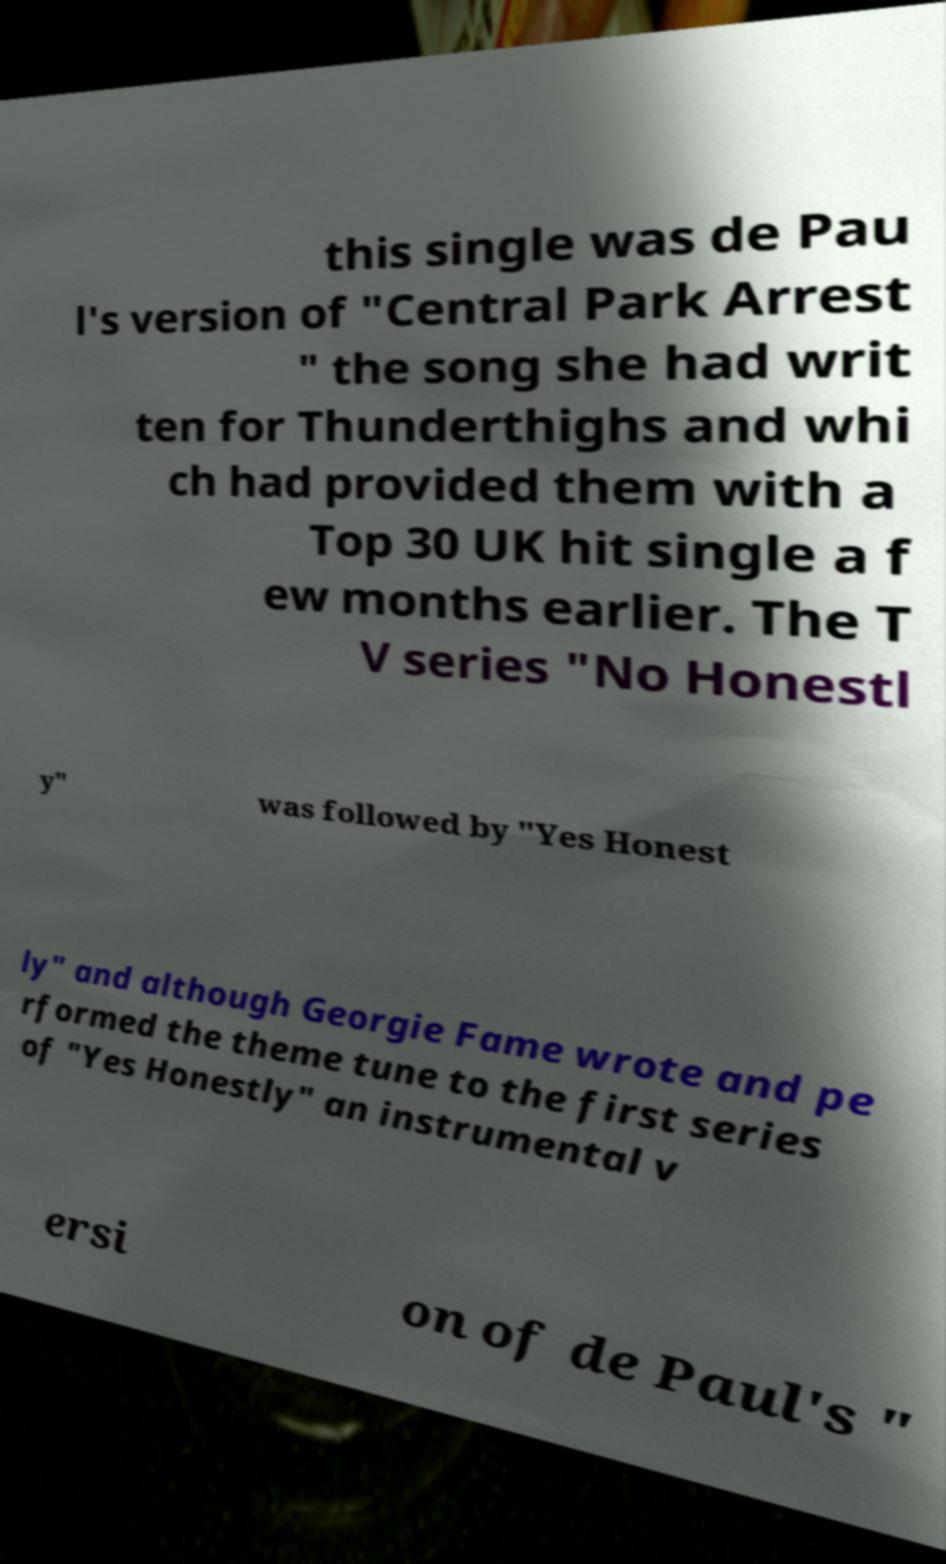Can you accurately transcribe the text from the provided image for me? this single was de Pau l's version of "Central Park Arrest " the song she had writ ten for Thunderthighs and whi ch had provided them with a Top 30 UK hit single a f ew months earlier. The T V series "No Honestl y" was followed by "Yes Honest ly" and although Georgie Fame wrote and pe rformed the theme tune to the first series of "Yes Honestly" an instrumental v ersi on of de Paul's " 